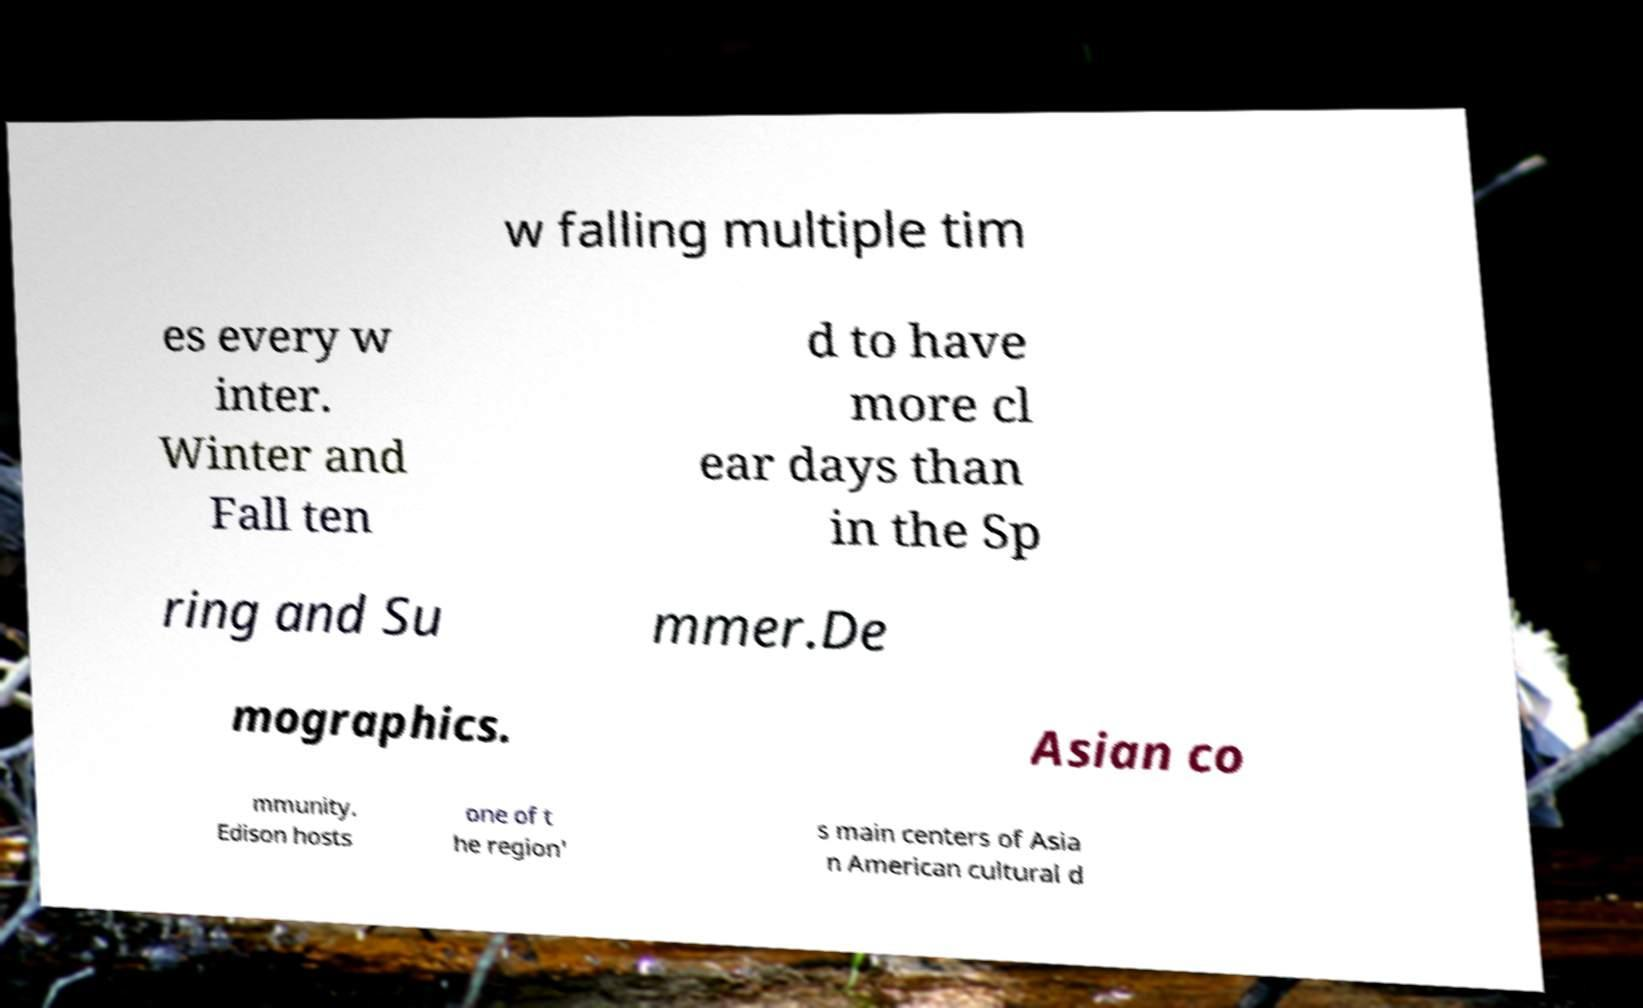Can you accurately transcribe the text from the provided image for me? w falling multiple tim es every w inter. Winter and Fall ten d to have more cl ear days than in the Sp ring and Su mmer.De mographics. Asian co mmunity. Edison hosts one of t he region' s main centers of Asia n American cultural d 